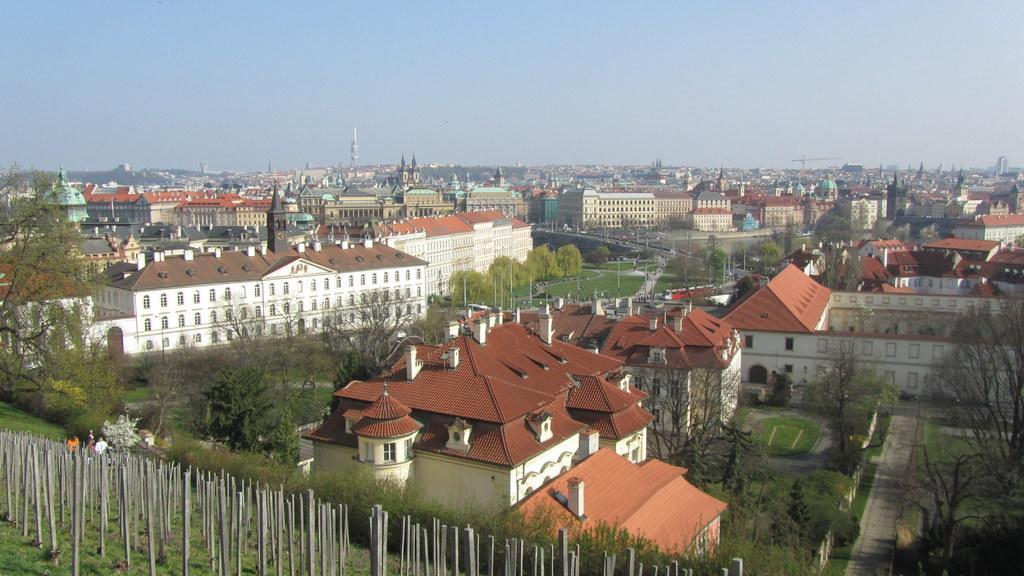In one or two sentences, can you explain what this image depicts? In the image we can see there are many buildings and windows of the building, there are poles, grass, trees, building crane, a path and a pale blue color sky. We can see there are even people wearing clothes. 